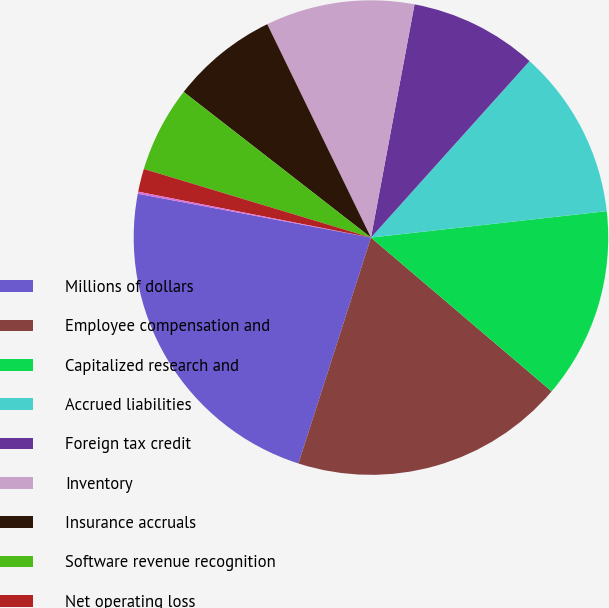Convert chart. <chart><loc_0><loc_0><loc_500><loc_500><pie_chart><fcel>Millions of dollars<fcel>Employee compensation and<fcel>Capitalized research and<fcel>Accrued liabilities<fcel>Foreign tax credit<fcel>Inventory<fcel>Insurance accruals<fcel>Software revenue recognition<fcel>Net operating loss<fcel>Alternative minimum tax credit<nl><fcel>23.01%<fcel>18.72%<fcel>13.0%<fcel>11.57%<fcel>8.71%<fcel>10.14%<fcel>7.28%<fcel>5.85%<fcel>1.57%<fcel>0.14%<nl></chart> 